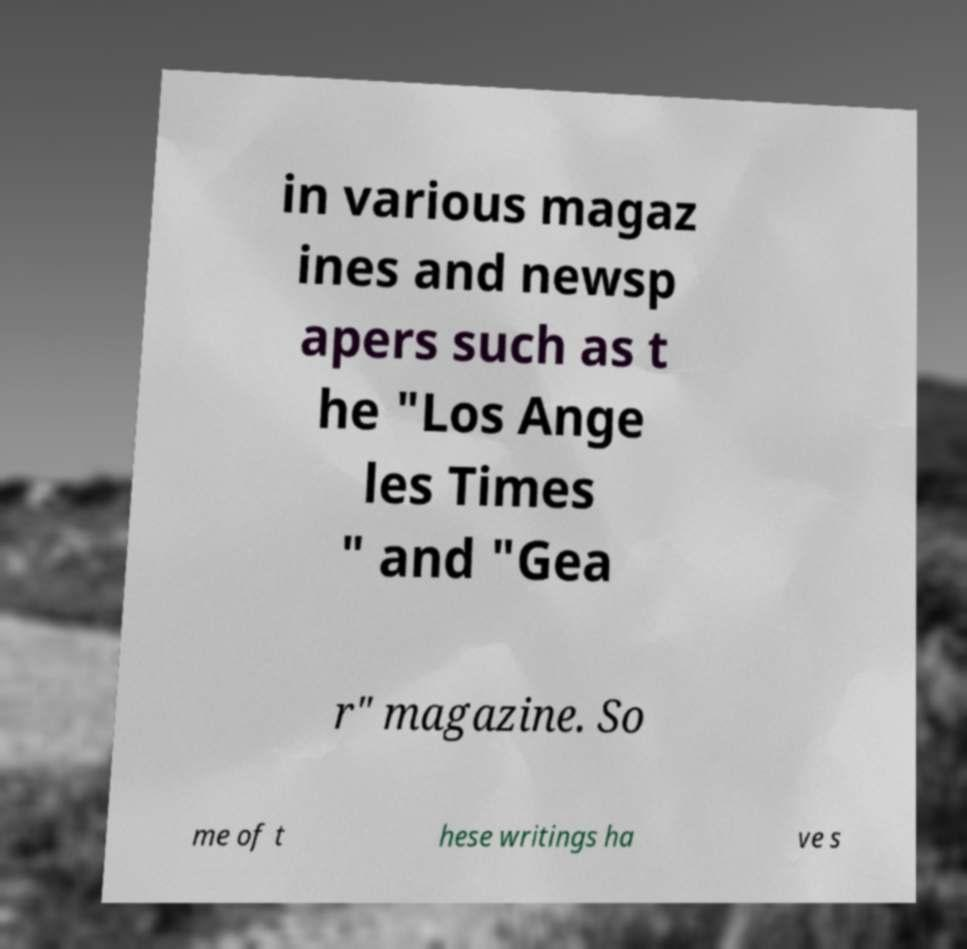Please read and relay the text visible in this image. What does it say? in various magaz ines and newsp apers such as t he "Los Ange les Times " and "Gea r" magazine. So me of t hese writings ha ve s 